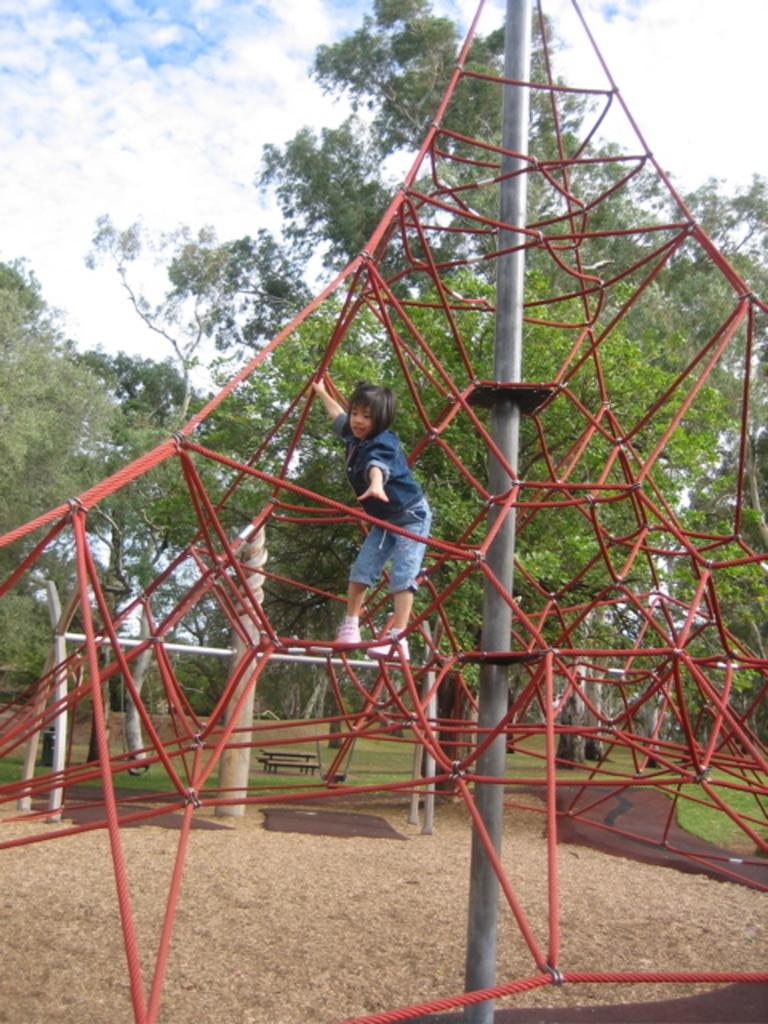What type of structure is present in the image? There is playground equipment in the image. Who is present near the playground equipment? A girl is standing on the equipment. What is the girl holding in the image? The girl is holding a rod. What can be seen in the background of the image? There are trees and the sky visible in the background of the image. How many brothers does the girl have, and are they present in the image? There is no information about the girl's brothers in the image, so we cannot determine their presence or number. Is the playground equipment located on an island in the image? There is no indication of an island in the image; it simply features playground equipment, a girl, and the background. 